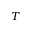Convert formula to latex. <formula><loc_0><loc_0><loc_500><loc_500>T</formula> 